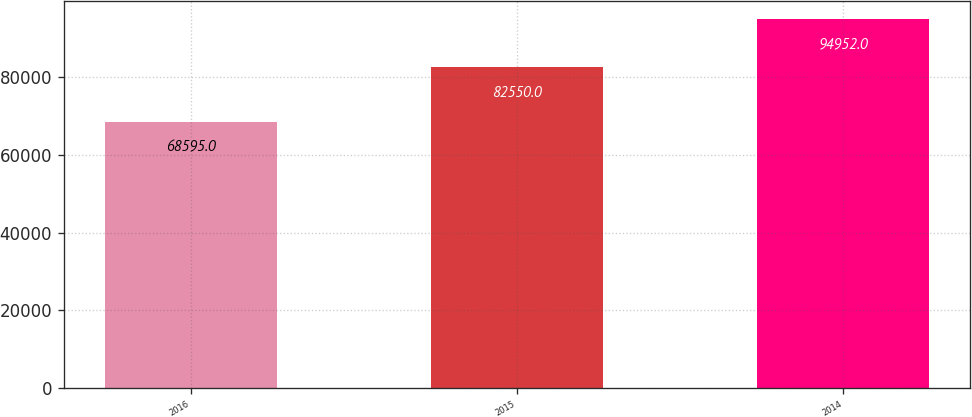Convert chart. <chart><loc_0><loc_0><loc_500><loc_500><bar_chart><fcel>2016<fcel>2015<fcel>2014<nl><fcel>68595<fcel>82550<fcel>94952<nl></chart> 